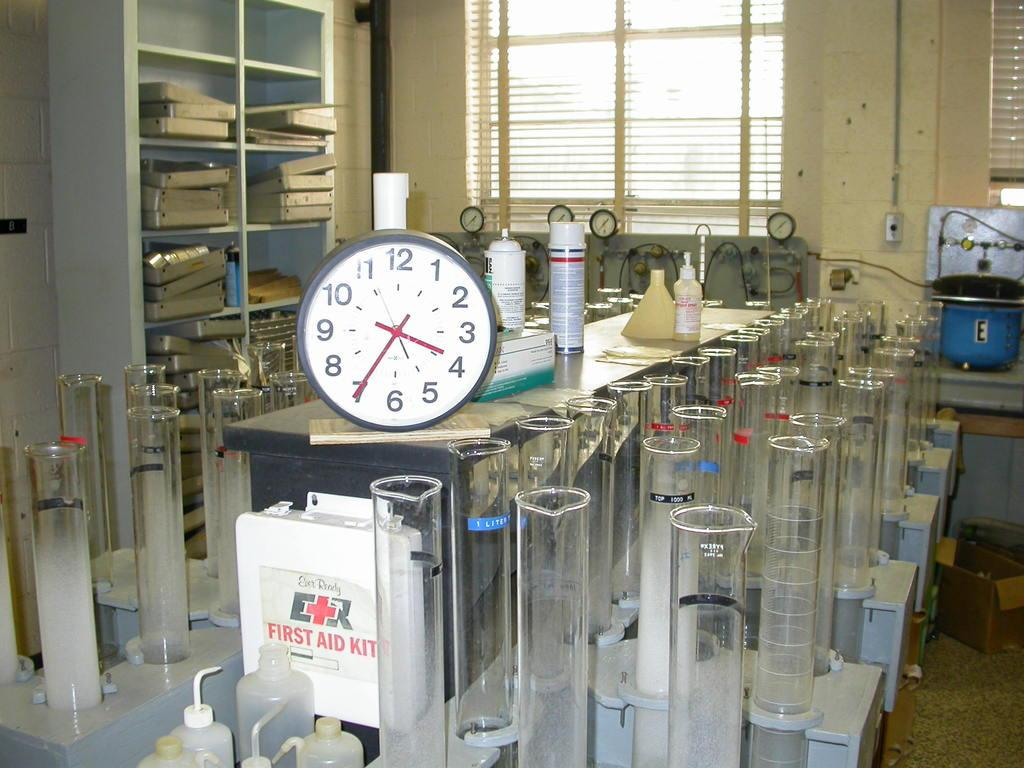Provide a one-sentence caption for the provided image. The time on the clock in the chemistry lab is 3:35. 